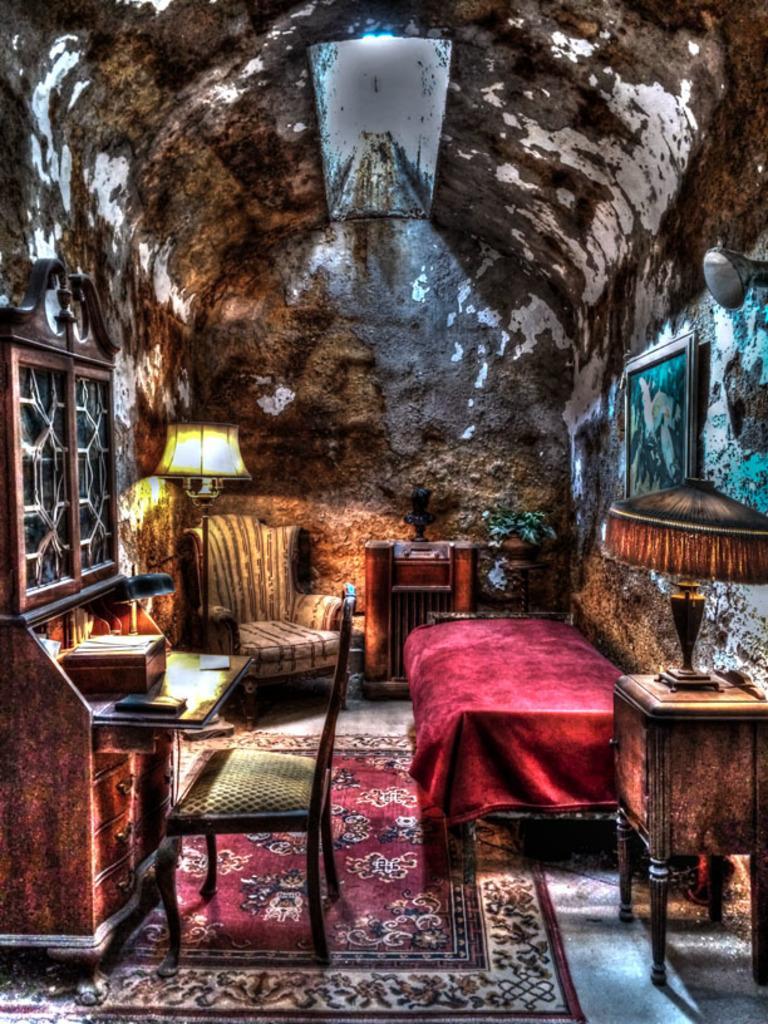Could you give a brief overview of what you see in this image? In this image in the center there is a bed, there is a sofa, there's an empty chair, there's a light lamp. On the right side there is frame on the wall and in front of the wall there is a table and on the table there is a light lamp. On the left side there is a cupboard. In the background there is a wall, and in front of the wall there is a wooden table. In the center on the floor there is mat. 